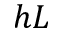Convert formula to latex. <formula><loc_0><loc_0><loc_500><loc_500>h L</formula> 